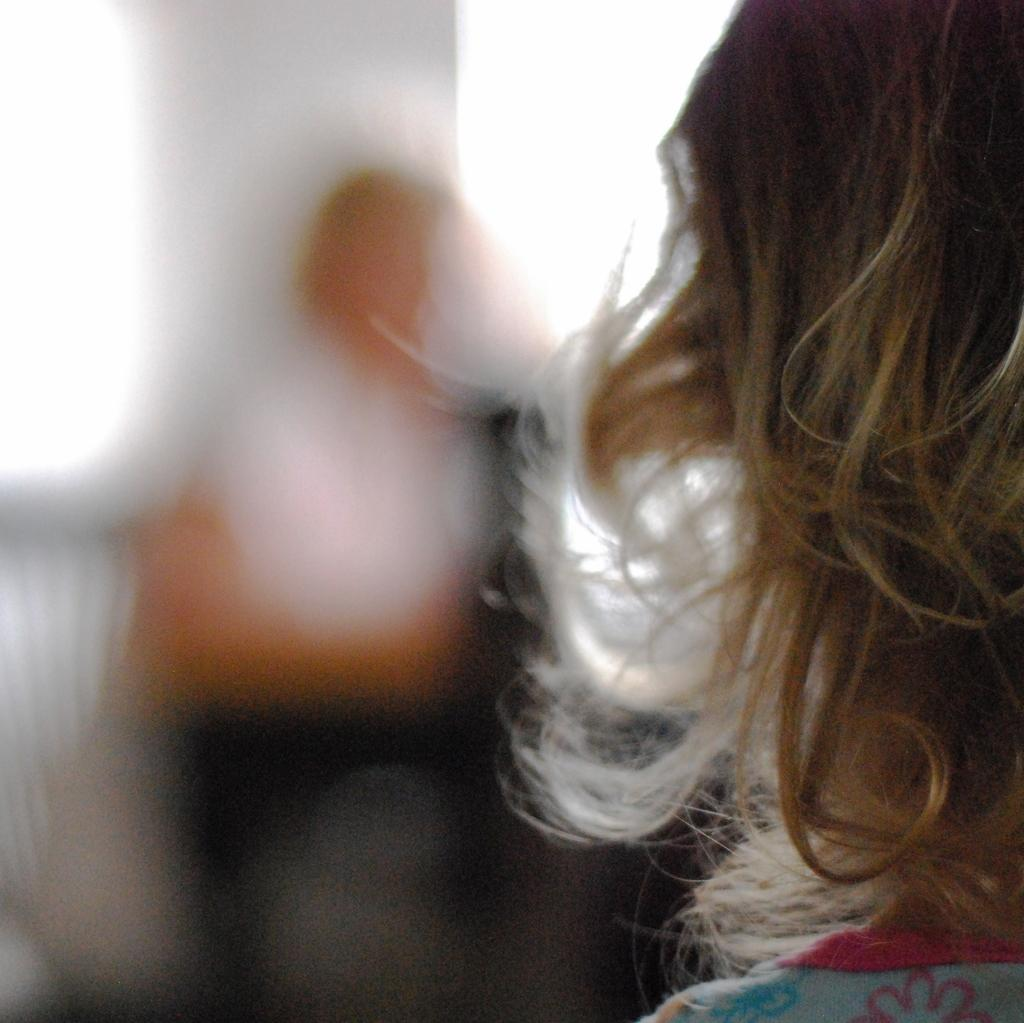What is the position of the person on the right side of the image? There is a person standing on the right side of the image. What is the position of the other person in the image? There is a person sitting in front of the standing person. What can be seen in the background of the image? There is a wall visible in the image. What type of corn is growing near the mailbox in the image? There is no mailbox or corn present in the image. What color is the flag flying near the wall in the image? There is no flag present in the image. 